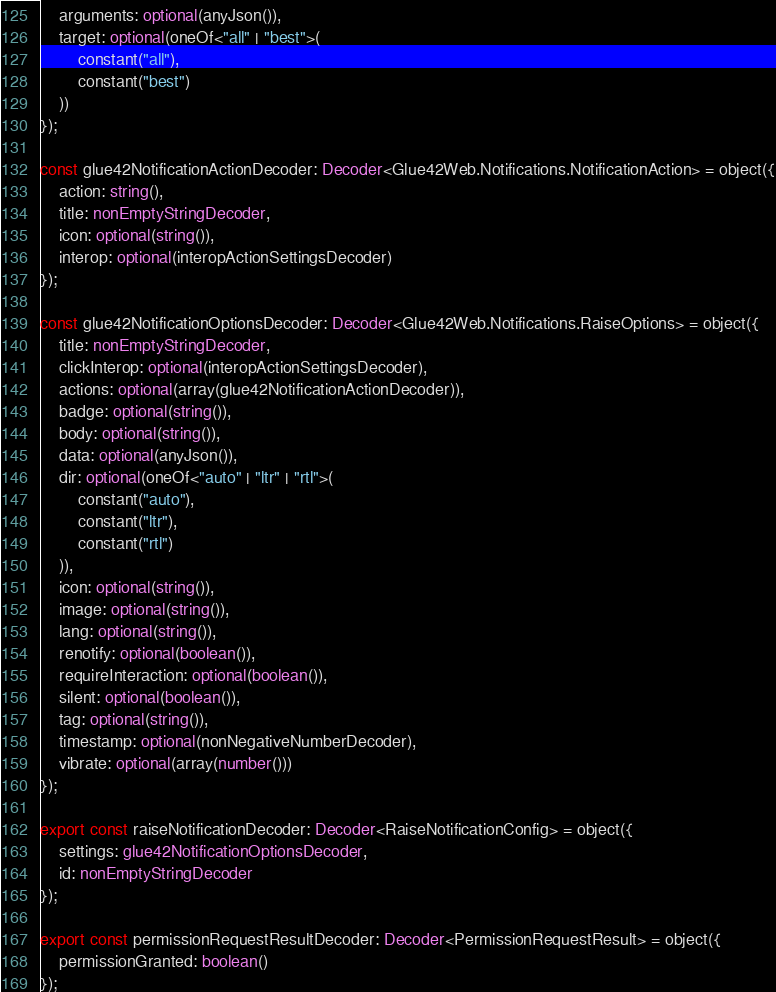Convert code to text. <code><loc_0><loc_0><loc_500><loc_500><_TypeScript_>    arguments: optional(anyJson()),
    target: optional(oneOf<"all" | "best">(
        constant("all"),
        constant("best")
    ))
});

const glue42NotificationActionDecoder: Decoder<Glue42Web.Notifications.NotificationAction> = object({
    action: string(),
    title: nonEmptyStringDecoder,
    icon: optional(string()),
    interop: optional(interopActionSettingsDecoder)
});

const glue42NotificationOptionsDecoder: Decoder<Glue42Web.Notifications.RaiseOptions> = object({
    title: nonEmptyStringDecoder,
    clickInterop: optional(interopActionSettingsDecoder),
    actions: optional(array(glue42NotificationActionDecoder)),
    badge: optional(string()),
    body: optional(string()),
    data: optional(anyJson()),
    dir: optional(oneOf<"auto" | "ltr" | "rtl">(
        constant("auto"),
        constant("ltr"),
        constant("rtl")
    )),
    icon: optional(string()),
    image: optional(string()),
    lang: optional(string()),
    renotify: optional(boolean()),
    requireInteraction: optional(boolean()),
    silent: optional(boolean()),
    tag: optional(string()),
    timestamp: optional(nonNegativeNumberDecoder),
    vibrate: optional(array(number()))
});

export const raiseNotificationDecoder: Decoder<RaiseNotificationConfig> = object({
    settings: glue42NotificationOptionsDecoder,
    id: nonEmptyStringDecoder
});

export const permissionRequestResultDecoder: Decoder<PermissionRequestResult> = object({
    permissionGranted: boolean()
});</code> 